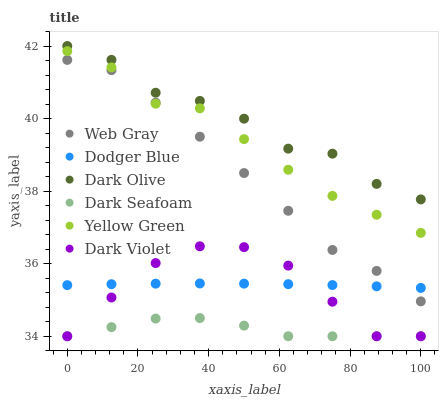Does Dark Seafoam have the minimum area under the curve?
Answer yes or no. Yes. Does Dark Olive have the maximum area under the curve?
Answer yes or no. Yes. Does Yellow Green have the minimum area under the curve?
Answer yes or no. No. Does Yellow Green have the maximum area under the curve?
Answer yes or no. No. Is Dodger Blue the smoothest?
Answer yes or no. Yes. Is Dark Olive the roughest?
Answer yes or no. Yes. Is Yellow Green the smoothest?
Answer yes or no. No. Is Yellow Green the roughest?
Answer yes or no. No. Does Dark Violet have the lowest value?
Answer yes or no. Yes. Does Yellow Green have the lowest value?
Answer yes or no. No. Does Dark Olive have the highest value?
Answer yes or no. Yes. Does Yellow Green have the highest value?
Answer yes or no. No. Is Dark Violet less than Web Gray?
Answer yes or no. Yes. Is Web Gray greater than Dark Violet?
Answer yes or no. Yes. Does Dark Violet intersect Dark Seafoam?
Answer yes or no. Yes. Is Dark Violet less than Dark Seafoam?
Answer yes or no. No. Is Dark Violet greater than Dark Seafoam?
Answer yes or no. No. Does Dark Violet intersect Web Gray?
Answer yes or no. No. 